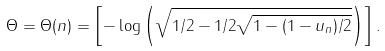Convert formula to latex. <formula><loc_0><loc_0><loc_500><loc_500>\Theta = \Theta ( n ) = \left [ - \log \left ( \sqrt { 1 / 2 - 1 / 2 \sqrt { 1 - ( 1 - u _ { n } ) / 2 } } \right ) \right ] .</formula> 